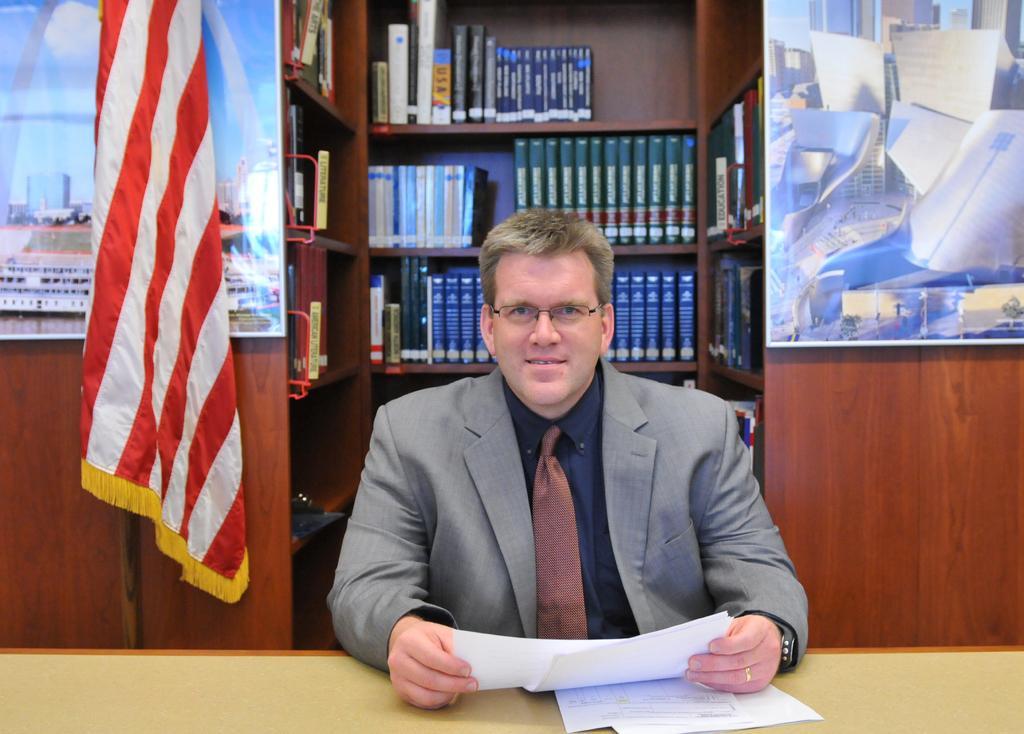In one or two sentences, can you explain what this image depicts? In this image there is a person, racks, pictures, flag and table. On the table there are papers. In the racks there are books. A person is holding papers. Pictures are on the wooden wall. 